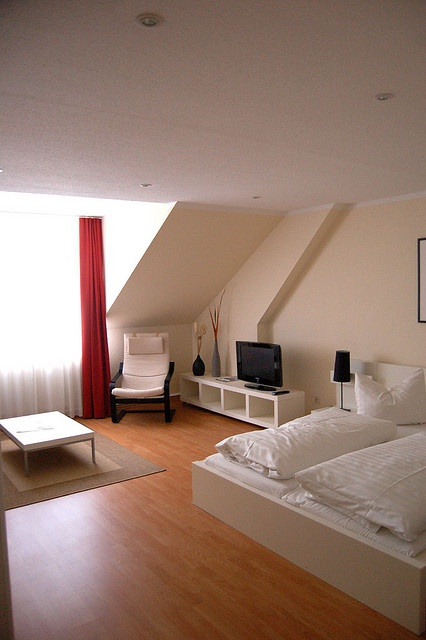Describe the objects in this image and their specific colors. I can see bed in black, gray, and darkgray tones, chair in black, darkgray, and gray tones, tv in black, gray, and maroon tones, vase in black, gray, and maroon tones, and vase in black, maroon, and gray tones in this image. 